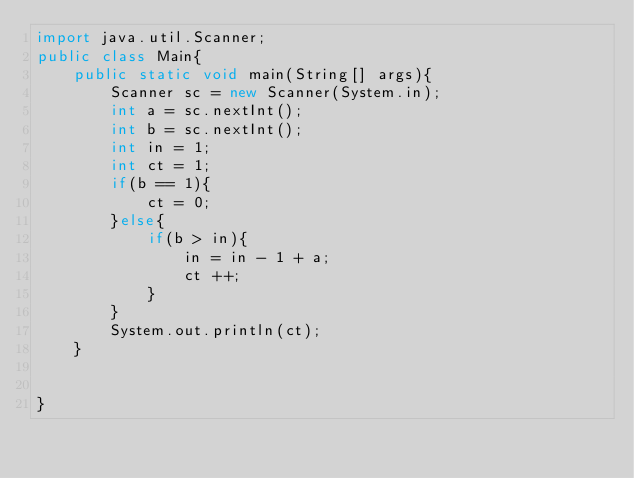Convert code to text. <code><loc_0><loc_0><loc_500><loc_500><_Java_>import java.util.Scanner;
public class Main{
	public static void main(String[] args){
		Scanner sc = new Scanner(System.in);
		int a = sc.nextInt();
		int b = sc.nextInt();
		int in = 1;
		int ct = 1;
		if(b == 1){
			ct = 0;
		}else{
			if(b > in){
				in = in - 1 + a;
				ct ++;
			}
		}
		System.out.println(ct);
	}


}</code> 